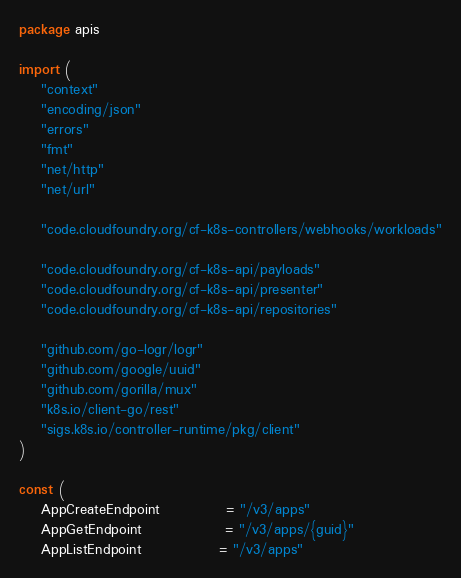Convert code to text. <code><loc_0><loc_0><loc_500><loc_500><_Go_>package apis

import (
	"context"
	"encoding/json"
	"errors"
	"fmt"
	"net/http"
	"net/url"

	"code.cloudfoundry.org/cf-k8s-controllers/webhooks/workloads"

	"code.cloudfoundry.org/cf-k8s-api/payloads"
	"code.cloudfoundry.org/cf-k8s-api/presenter"
	"code.cloudfoundry.org/cf-k8s-api/repositories"

	"github.com/go-logr/logr"
	"github.com/google/uuid"
	"github.com/gorilla/mux"
	"k8s.io/client-go/rest"
	"sigs.k8s.io/controller-runtime/pkg/client"
)

const (
	AppCreateEndpoint            = "/v3/apps"
	AppGetEndpoint               = "/v3/apps/{guid}"
	AppListEndpoint              = "/v3/apps"</code> 